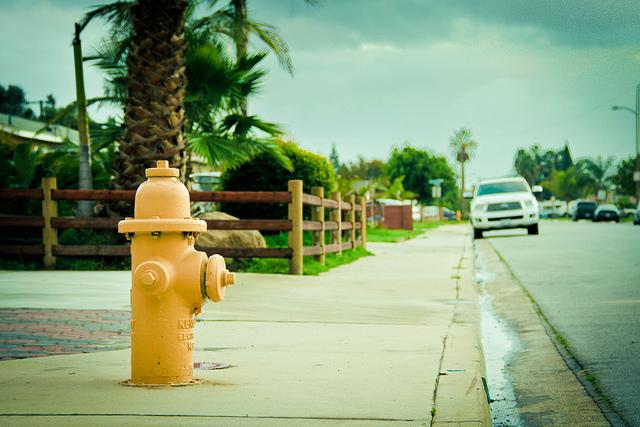What kind of weather is one likely to experience in this area? Please explain your reasoning. tropical. Palm trees are seen in the area which only grow where it is warm year-round. 